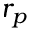Convert formula to latex. <formula><loc_0><loc_0><loc_500><loc_500>r _ { p }</formula> 